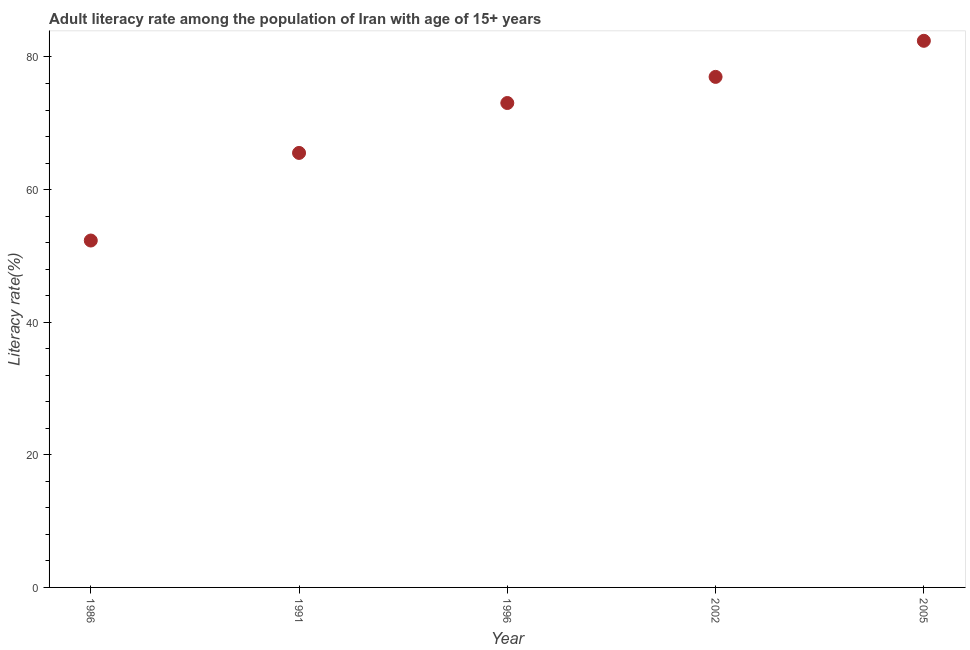What is the adult literacy rate in 1991?
Offer a very short reply. 65.53. Across all years, what is the maximum adult literacy rate?
Provide a short and direct response. 82.44. Across all years, what is the minimum adult literacy rate?
Ensure brevity in your answer.  52.32. In which year was the adult literacy rate minimum?
Offer a very short reply. 1986. What is the sum of the adult literacy rate?
Your answer should be very brief. 350.35. What is the difference between the adult literacy rate in 1986 and 2002?
Your answer should be compact. -24.68. What is the average adult literacy rate per year?
Your answer should be compact. 70.07. What is the median adult literacy rate?
Offer a very short reply. 73.06. In how many years, is the adult literacy rate greater than 44 %?
Provide a short and direct response. 5. What is the ratio of the adult literacy rate in 1991 to that in 2002?
Offer a very short reply. 0.85. Is the adult literacy rate in 1991 less than that in 2002?
Provide a succinct answer. Yes. Is the difference between the adult literacy rate in 1991 and 2002 greater than the difference between any two years?
Provide a short and direct response. No. What is the difference between the highest and the second highest adult literacy rate?
Give a very brief answer. 5.44. Is the sum of the adult literacy rate in 1996 and 2002 greater than the maximum adult literacy rate across all years?
Make the answer very short. Yes. What is the difference between the highest and the lowest adult literacy rate?
Your answer should be compact. 30.12. Does the adult literacy rate monotonically increase over the years?
Provide a short and direct response. Yes. How many dotlines are there?
Make the answer very short. 1. Are the values on the major ticks of Y-axis written in scientific E-notation?
Give a very brief answer. No. What is the title of the graph?
Make the answer very short. Adult literacy rate among the population of Iran with age of 15+ years. What is the label or title of the Y-axis?
Offer a very short reply. Literacy rate(%). What is the Literacy rate(%) in 1986?
Make the answer very short. 52.32. What is the Literacy rate(%) in 1991?
Your answer should be compact. 65.53. What is the Literacy rate(%) in 1996?
Make the answer very short. 73.06. What is the Literacy rate(%) in 2005?
Ensure brevity in your answer.  82.44. What is the difference between the Literacy rate(%) in 1986 and 1991?
Provide a short and direct response. -13.21. What is the difference between the Literacy rate(%) in 1986 and 1996?
Your answer should be compact. -20.74. What is the difference between the Literacy rate(%) in 1986 and 2002?
Make the answer very short. -24.68. What is the difference between the Literacy rate(%) in 1986 and 2005?
Offer a very short reply. -30.12. What is the difference between the Literacy rate(%) in 1991 and 1996?
Provide a succinct answer. -7.53. What is the difference between the Literacy rate(%) in 1991 and 2002?
Your answer should be compact. -11.47. What is the difference between the Literacy rate(%) in 1991 and 2005?
Your answer should be compact. -16.91. What is the difference between the Literacy rate(%) in 1996 and 2002?
Your response must be concise. -3.94. What is the difference between the Literacy rate(%) in 1996 and 2005?
Give a very brief answer. -9.38. What is the difference between the Literacy rate(%) in 2002 and 2005?
Your answer should be compact. -5.44. What is the ratio of the Literacy rate(%) in 1986 to that in 1991?
Your response must be concise. 0.8. What is the ratio of the Literacy rate(%) in 1986 to that in 1996?
Provide a short and direct response. 0.72. What is the ratio of the Literacy rate(%) in 1986 to that in 2002?
Offer a very short reply. 0.68. What is the ratio of the Literacy rate(%) in 1986 to that in 2005?
Make the answer very short. 0.64. What is the ratio of the Literacy rate(%) in 1991 to that in 1996?
Ensure brevity in your answer.  0.9. What is the ratio of the Literacy rate(%) in 1991 to that in 2002?
Ensure brevity in your answer.  0.85. What is the ratio of the Literacy rate(%) in 1991 to that in 2005?
Your response must be concise. 0.8. What is the ratio of the Literacy rate(%) in 1996 to that in 2002?
Keep it short and to the point. 0.95. What is the ratio of the Literacy rate(%) in 1996 to that in 2005?
Ensure brevity in your answer.  0.89. What is the ratio of the Literacy rate(%) in 2002 to that in 2005?
Ensure brevity in your answer.  0.93. 